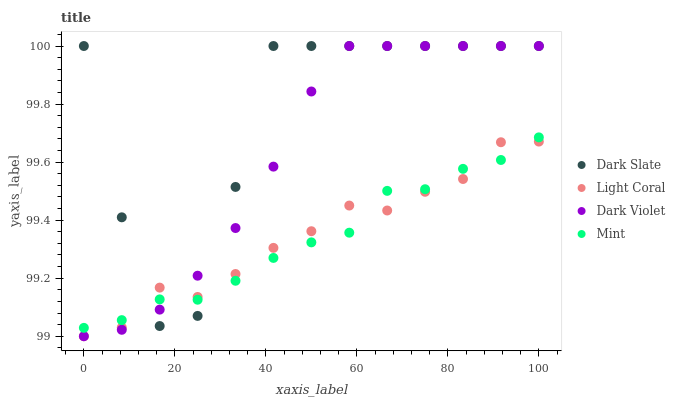Does Mint have the minimum area under the curve?
Answer yes or no. Yes. Does Dark Slate have the maximum area under the curve?
Answer yes or no. Yes. Does Dark Slate have the minimum area under the curve?
Answer yes or no. No. Does Mint have the maximum area under the curve?
Answer yes or no. No. Is Dark Violet the smoothest?
Answer yes or no. Yes. Is Dark Slate the roughest?
Answer yes or no. Yes. Is Mint the smoothest?
Answer yes or no. No. Is Mint the roughest?
Answer yes or no. No. Does Light Coral have the lowest value?
Answer yes or no. Yes. Does Mint have the lowest value?
Answer yes or no. No. Does Dark Violet have the highest value?
Answer yes or no. Yes. Does Mint have the highest value?
Answer yes or no. No. Does Dark Violet intersect Mint?
Answer yes or no. Yes. Is Dark Violet less than Mint?
Answer yes or no. No. Is Dark Violet greater than Mint?
Answer yes or no. No. 